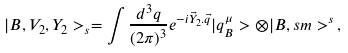Convert formula to latex. <formula><loc_0><loc_0><loc_500><loc_500>| B , V _ { 2 } , Y _ { 2 } > _ { s } = \int \frac { d ^ { 3 } q } { ( 2 \pi ) ^ { 3 } } e ^ { - i \vec { Y } _ { 2 } . \vec { q } } | q ^ { \mu } _ { B } > \otimes | B , s m > ^ { s } \, ,</formula> 